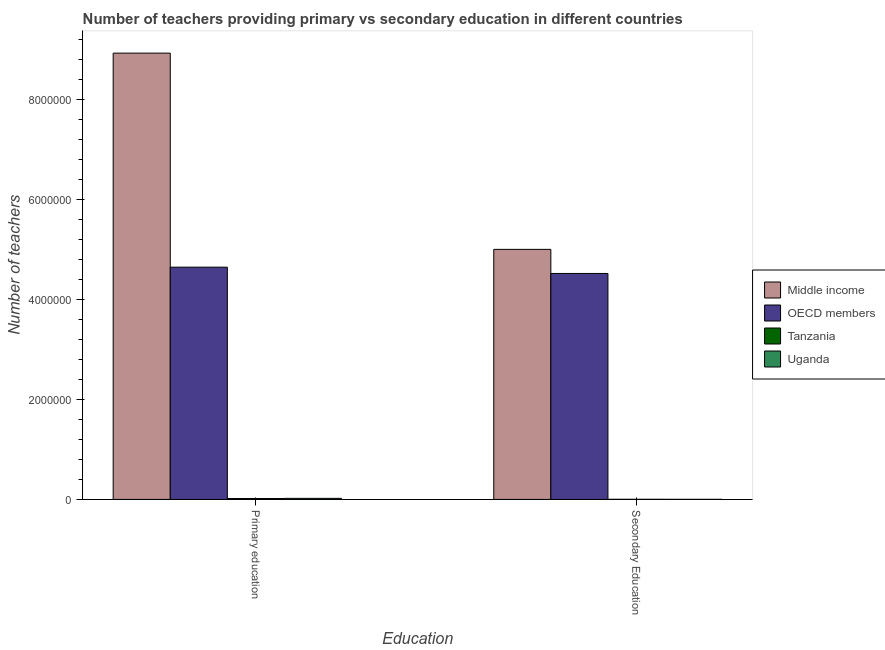How many different coloured bars are there?
Offer a very short reply. 4. How many bars are there on the 1st tick from the left?
Give a very brief answer. 4. What is the label of the 2nd group of bars from the left?
Offer a terse response. Secondary Education. What is the number of secondary teachers in OECD members?
Your response must be concise. 4.52e+06. Across all countries, what is the maximum number of primary teachers?
Ensure brevity in your answer.  8.93e+06. Across all countries, what is the minimum number of secondary teachers?
Offer a very short reply. 1816. In which country was the number of primary teachers minimum?
Make the answer very short. Tanzania. What is the total number of secondary teachers in the graph?
Make the answer very short. 9.53e+06. What is the difference between the number of secondary teachers in Middle income and that in OECD members?
Provide a succinct answer. 4.82e+05. What is the difference between the number of primary teachers in OECD members and the number of secondary teachers in Tanzania?
Provide a short and direct response. 4.64e+06. What is the average number of secondary teachers per country?
Make the answer very short. 2.38e+06. What is the difference between the number of secondary teachers and number of primary teachers in Uganda?
Provide a succinct answer. -1.97e+04. In how many countries, is the number of secondary teachers greater than 1200000 ?
Your answer should be very brief. 2. What is the ratio of the number of secondary teachers in Tanzania to that in Middle income?
Your answer should be very brief. 0. In how many countries, is the number of primary teachers greater than the average number of primary teachers taken over all countries?
Provide a succinct answer. 2. What does the 3rd bar from the left in Secondary Education represents?
Make the answer very short. Tanzania. How many countries are there in the graph?
Provide a short and direct response. 4. Does the graph contain any zero values?
Your answer should be compact. No. Where does the legend appear in the graph?
Give a very brief answer. Center right. How many legend labels are there?
Your answer should be very brief. 4. What is the title of the graph?
Ensure brevity in your answer.  Number of teachers providing primary vs secondary education in different countries. Does "Grenada" appear as one of the legend labels in the graph?
Provide a short and direct response. No. What is the label or title of the X-axis?
Offer a terse response. Education. What is the label or title of the Y-axis?
Ensure brevity in your answer.  Number of teachers. What is the Number of teachers in Middle income in Primary education?
Your answer should be compact. 8.93e+06. What is the Number of teachers in OECD members in Primary education?
Provide a succinct answer. 4.65e+06. What is the Number of teachers of Tanzania in Primary education?
Keep it short and to the point. 1.83e+04. What is the Number of teachers of Uganda in Primary education?
Make the answer very short. 2.15e+04. What is the Number of teachers of Middle income in Secondary Education?
Make the answer very short. 5.00e+06. What is the Number of teachers in OECD members in Secondary Education?
Provide a succinct answer. 4.52e+06. What is the Number of teachers of Tanzania in Secondary Education?
Provide a short and direct response. 2449. What is the Number of teachers of Uganda in Secondary Education?
Your answer should be very brief. 1816. Across all Education, what is the maximum Number of teachers of Middle income?
Provide a succinct answer. 8.93e+06. Across all Education, what is the maximum Number of teachers of OECD members?
Provide a succinct answer. 4.65e+06. Across all Education, what is the maximum Number of teachers of Tanzania?
Your answer should be very brief. 1.83e+04. Across all Education, what is the maximum Number of teachers in Uganda?
Give a very brief answer. 2.15e+04. Across all Education, what is the minimum Number of teachers of Middle income?
Your response must be concise. 5.00e+06. Across all Education, what is the minimum Number of teachers in OECD members?
Your answer should be compact. 4.52e+06. Across all Education, what is the minimum Number of teachers of Tanzania?
Your answer should be compact. 2449. Across all Education, what is the minimum Number of teachers in Uganda?
Keep it short and to the point. 1816. What is the total Number of teachers of Middle income in the graph?
Provide a short and direct response. 1.39e+07. What is the total Number of teachers of OECD members in the graph?
Your answer should be compact. 9.16e+06. What is the total Number of teachers in Tanzania in the graph?
Your answer should be very brief. 2.08e+04. What is the total Number of teachers in Uganda in the graph?
Your answer should be very brief. 2.33e+04. What is the difference between the Number of teachers of Middle income in Primary education and that in Secondary Education?
Your answer should be very brief. 3.92e+06. What is the difference between the Number of teachers in OECD members in Primary education and that in Secondary Education?
Ensure brevity in your answer.  1.26e+05. What is the difference between the Number of teachers of Tanzania in Primary education and that in Secondary Education?
Provide a short and direct response. 1.59e+04. What is the difference between the Number of teachers of Uganda in Primary education and that in Secondary Education?
Your response must be concise. 1.97e+04. What is the difference between the Number of teachers in Middle income in Primary education and the Number of teachers in OECD members in Secondary Education?
Offer a terse response. 4.41e+06. What is the difference between the Number of teachers of Middle income in Primary education and the Number of teachers of Tanzania in Secondary Education?
Provide a short and direct response. 8.92e+06. What is the difference between the Number of teachers of Middle income in Primary education and the Number of teachers of Uganda in Secondary Education?
Your answer should be compact. 8.92e+06. What is the difference between the Number of teachers in OECD members in Primary education and the Number of teachers in Tanzania in Secondary Education?
Ensure brevity in your answer.  4.64e+06. What is the difference between the Number of teachers in OECD members in Primary education and the Number of teachers in Uganda in Secondary Education?
Offer a very short reply. 4.64e+06. What is the difference between the Number of teachers in Tanzania in Primary education and the Number of teachers in Uganda in Secondary Education?
Ensure brevity in your answer.  1.65e+04. What is the average Number of teachers of Middle income per Education?
Provide a short and direct response. 6.96e+06. What is the average Number of teachers of OECD members per Education?
Ensure brevity in your answer.  4.58e+06. What is the average Number of teachers in Tanzania per Education?
Keep it short and to the point. 1.04e+04. What is the average Number of teachers of Uganda per Education?
Offer a very short reply. 1.16e+04. What is the difference between the Number of teachers of Middle income and Number of teachers of OECD members in Primary education?
Your response must be concise. 4.28e+06. What is the difference between the Number of teachers of Middle income and Number of teachers of Tanzania in Primary education?
Give a very brief answer. 8.91e+06. What is the difference between the Number of teachers of Middle income and Number of teachers of Uganda in Primary education?
Your answer should be very brief. 8.90e+06. What is the difference between the Number of teachers of OECD members and Number of teachers of Tanzania in Primary education?
Provide a short and direct response. 4.63e+06. What is the difference between the Number of teachers in OECD members and Number of teachers in Uganda in Primary education?
Your answer should be very brief. 4.62e+06. What is the difference between the Number of teachers in Tanzania and Number of teachers in Uganda in Primary education?
Ensure brevity in your answer.  -3158. What is the difference between the Number of teachers of Middle income and Number of teachers of OECD members in Secondary Education?
Ensure brevity in your answer.  4.82e+05. What is the difference between the Number of teachers of Middle income and Number of teachers of Tanzania in Secondary Education?
Your response must be concise. 5.00e+06. What is the difference between the Number of teachers of Middle income and Number of teachers of Uganda in Secondary Education?
Offer a terse response. 5.00e+06. What is the difference between the Number of teachers in OECD members and Number of teachers in Tanzania in Secondary Education?
Your answer should be very brief. 4.52e+06. What is the difference between the Number of teachers in OECD members and Number of teachers in Uganda in Secondary Education?
Give a very brief answer. 4.52e+06. What is the difference between the Number of teachers of Tanzania and Number of teachers of Uganda in Secondary Education?
Offer a terse response. 633. What is the ratio of the Number of teachers of Middle income in Primary education to that in Secondary Education?
Ensure brevity in your answer.  1.78. What is the ratio of the Number of teachers of OECD members in Primary education to that in Secondary Education?
Give a very brief answer. 1.03. What is the ratio of the Number of teachers in Tanzania in Primary education to that in Secondary Education?
Provide a short and direct response. 7.48. What is the ratio of the Number of teachers in Uganda in Primary education to that in Secondary Education?
Your answer should be very brief. 11.82. What is the difference between the highest and the second highest Number of teachers of Middle income?
Offer a very short reply. 3.92e+06. What is the difference between the highest and the second highest Number of teachers of OECD members?
Ensure brevity in your answer.  1.26e+05. What is the difference between the highest and the second highest Number of teachers of Tanzania?
Your answer should be very brief. 1.59e+04. What is the difference between the highest and the second highest Number of teachers of Uganda?
Your answer should be compact. 1.97e+04. What is the difference between the highest and the lowest Number of teachers of Middle income?
Offer a terse response. 3.92e+06. What is the difference between the highest and the lowest Number of teachers in OECD members?
Your answer should be compact. 1.26e+05. What is the difference between the highest and the lowest Number of teachers of Tanzania?
Your answer should be compact. 1.59e+04. What is the difference between the highest and the lowest Number of teachers of Uganda?
Keep it short and to the point. 1.97e+04. 